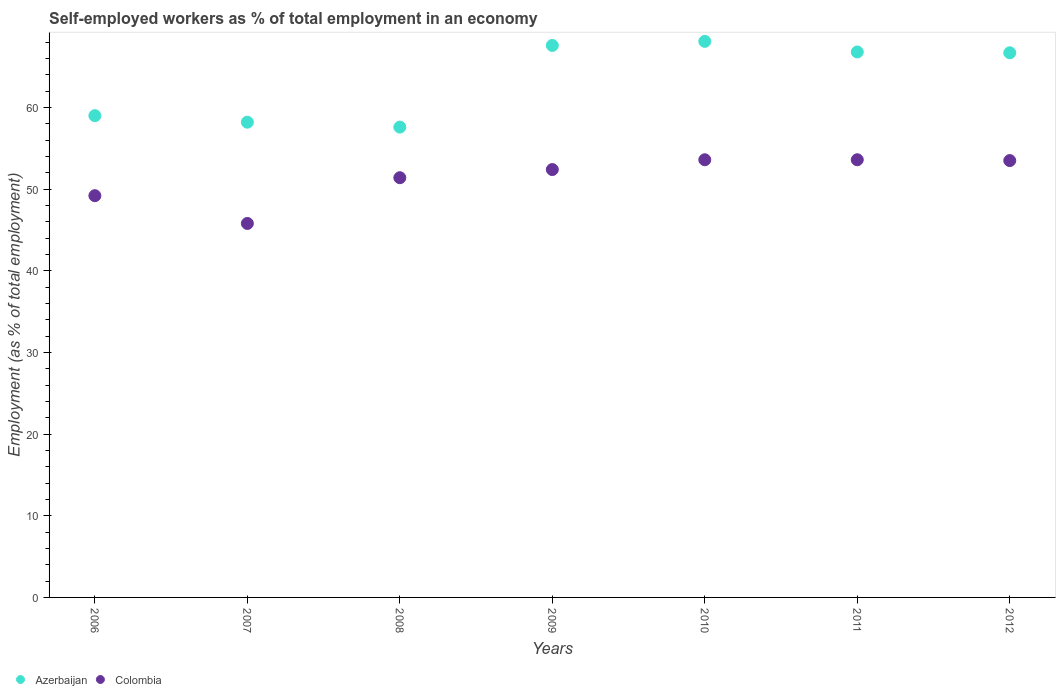How many different coloured dotlines are there?
Your answer should be compact. 2. What is the percentage of self-employed workers in Azerbaijan in 2008?
Your response must be concise. 57.6. Across all years, what is the maximum percentage of self-employed workers in Azerbaijan?
Keep it short and to the point. 68.1. Across all years, what is the minimum percentage of self-employed workers in Azerbaijan?
Give a very brief answer. 57.6. What is the total percentage of self-employed workers in Azerbaijan in the graph?
Your answer should be compact. 444. What is the difference between the percentage of self-employed workers in Azerbaijan in 2009 and that in 2012?
Provide a short and direct response. 0.9. What is the difference between the percentage of self-employed workers in Colombia in 2011 and the percentage of self-employed workers in Azerbaijan in 2012?
Provide a short and direct response. -13.1. What is the average percentage of self-employed workers in Azerbaijan per year?
Give a very brief answer. 63.43. In the year 2011, what is the difference between the percentage of self-employed workers in Colombia and percentage of self-employed workers in Azerbaijan?
Provide a succinct answer. -13.2. In how many years, is the percentage of self-employed workers in Colombia greater than 66 %?
Keep it short and to the point. 0. What is the ratio of the percentage of self-employed workers in Colombia in 2007 to that in 2011?
Keep it short and to the point. 0.85. Is the percentage of self-employed workers in Azerbaijan in 2010 less than that in 2012?
Offer a very short reply. No. What is the difference between the highest and the second highest percentage of self-employed workers in Azerbaijan?
Make the answer very short. 0.5. What is the difference between the highest and the lowest percentage of self-employed workers in Azerbaijan?
Offer a terse response. 10.5. Is the sum of the percentage of self-employed workers in Colombia in 2010 and 2011 greater than the maximum percentage of self-employed workers in Azerbaijan across all years?
Your response must be concise. Yes. Is the percentage of self-employed workers in Colombia strictly less than the percentage of self-employed workers in Azerbaijan over the years?
Your answer should be compact. Yes. How many years are there in the graph?
Make the answer very short. 7. Are the values on the major ticks of Y-axis written in scientific E-notation?
Provide a succinct answer. No. Where does the legend appear in the graph?
Keep it short and to the point. Bottom left. What is the title of the graph?
Your answer should be very brief. Self-employed workers as % of total employment in an economy. What is the label or title of the X-axis?
Provide a short and direct response. Years. What is the label or title of the Y-axis?
Ensure brevity in your answer.  Employment (as % of total employment). What is the Employment (as % of total employment) in Azerbaijan in 2006?
Provide a short and direct response. 59. What is the Employment (as % of total employment) of Colombia in 2006?
Ensure brevity in your answer.  49.2. What is the Employment (as % of total employment) of Azerbaijan in 2007?
Provide a short and direct response. 58.2. What is the Employment (as % of total employment) in Colombia in 2007?
Offer a very short reply. 45.8. What is the Employment (as % of total employment) in Azerbaijan in 2008?
Your answer should be very brief. 57.6. What is the Employment (as % of total employment) in Colombia in 2008?
Provide a succinct answer. 51.4. What is the Employment (as % of total employment) in Azerbaijan in 2009?
Your response must be concise. 67.6. What is the Employment (as % of total employment) of Colombia in 2009?
Offer a very short reply. 52.4. What is the Employment (as % of total employment) in Azerbaijan in 2010?
Keep it short and to the point. 68.1. What is the Employment (as % of total employment) in Colombia in 2010?
Offer a terse response. 53.6. What is the Employment (as % of total employment) of Azerbaijan in 2011?
Offer a terse response. 66.8. What is the Employment (as % of total employment) in Colombia in 2011?
Your response must be concise. 53.6. What is the Employment (as % of total employment) of Azerbaijan in 2012?
Provide a succinct answer. 66.7. What is the Employment (as % of total employment) in Colombia in 2012?
Keep it short and to the point. 53.5. Across all years, what is the maximum Employment (as % of total employment) in Azerbaijan?
Offer a very short reply. 68.1. Across all years, what is the maximum Employment (as % of total employment) in Colombia?
Offer a very short reply. 53.6. Across all years, what is the minimum Employment (as % of total employment) in Azerbaijan?
Ensure brevity in your answer.  57.6. Across all years, what is the minimum Employment (as % of total employment) of Colombia?
Give a very brief answer. 45.8. What is the total Employment (as % of total employment) in Azerbaijan in the graph?
Offer a terse response. 444. What is the total Employment (as % of total employment) of Colombia in the graph?
Make the answer very short. 359.5. What is the difference between the Employment (as % of total employment) in Azerbaijan in 2006 and that in 2007?
Keep it short and to the point. 0.8. What is the difference between the Employment (as % of total employment) of Colombia in 2006 and that in 2007?
Your response must be concise. 3.4. What is the difference between the Employment (as % of total employment) in Azerbaijan in 2006 and that in 2009?
Your response must be concise. -8.6. What is the difference between the Employment (as % of total employment) in Azerbaijan in 2006 and that in 2010?
Provide a succinct answer. -9.1. What is the difference between the Employment (as % of total employment) in Colombia in 2006 and that in 2010?
Your response must be concise. -4.4. What is the difference between the Employment (as % of total employment) of Azerbaijan in 2006 and that in 2011?
Keep it short and to the point. -7.8. What is the difference between the Employment (as % of total employment) of Azerbaijan in 2006 and that in 2012?
Your answer should be compact. -7.7. What is the difference between the Employment (as % of total employment) of Azerbaijan in 2007 and that in 2008?
Your answer should be very brief. 0.6. What is the difference between the Employment (as % of total employment) in Colombia in 2007 and that in 2008?
Offer a very short reply. -5.6. What is the difference between the Employment (as % of total employment) in Colombia in 2007 and that in 2009?
Offer a terse response. -6.6. What is the difference between the Employment (as % of total employment) of Azerbaijan in 2007 and that in 2011?
Keep it short and to the point. -8.6. What is the difference between the Employment (as % of total employment) of Colombia in 2007 and that in 2012?
Provide a short and direct response. -7.7. What is the difference between the Employment (as % of total employment) in Colombia in 2008 and that in 2010?
Keep it short and to the point. -2.2. What is the difference between the Employment (as % of total employment) of Azerbaijan in 2008 and that in 2011?
Make the answer very short. -9.2. What is the difference between the Employment (as % of total employment) in Azerbaijan in 2008 and that in 2012?
Provide a short and direct response. -9.1. What is the difference between the Employment (as % of total employment) of Colombia in 2008 and that in 2012?
Provide a succinct answer. -2.1. What is the difference between the Employment (as % of total employment) of Azerbaijan in 2009 and that in 2011?
Provide a short and direct response. 0.8. What is the difference between the Employment (as % of total employment) in Colombia in 2009 and that in 2012?
Keep it short and to the point. -1.1. What is the difference between the Employment (as % of total employment) in Azerbaijan in 2010 and that in 2011?
Offer a very short reply. 1.3. What is the difference between the Employment (as % of total employment) in Azerbaijan in 2011 and that in 2012?
Ensure brevity in your answer.  0.1. What is the difference between the Employment (as % of total employment) in Azerbaijan in 2006 and the Employment (as % of total employment) in Colombia in 2009?
Your answer should be compact. 6.6. What is the difference between the Employment (as % of total employment) in Azerbaijan in 2006 and the Employment (as % of total employment) in Colombia in 2011?
Give a very brief answer. 5.4. What is the difference between the Employment (as % of total employment) of Azerbaijan in 2007 and the Employment (as % of total employment) of Colombia in 2008?
Your response must be concise. 6.8. What is the difference between the Employment (as % of total employment) in Azerbaijan in 2007 and the Employment (as % of total employment) in Colombia in 2009?
Keep it short and to the point. 5.8. What is the difference between the Employment (as % of total employment) in Azerbaijan in 2007 and the Employment (as % of total employment) in Colombia in 2011?
Ensure brevity in your answer.  4.6. What is the difference between the Employment (as % of total employment) of Azerbaijan in 2007 and the Employment (as % of total employment) of Colombia in 2012?
Give a very brief answer. 4.7. What is the difference between the Employment (as % of total employment) in Azerbaijan in 2008 and the Employment (as % of total employment) in Colombia in 2012?
Your answer should be compact. 4.1. What is the difference between the Employment (as % of total employment) of Azerbaijan in 2009 and the Employment (as % of total employment) of Colombia in 2011?
Offer a very short reply. 14. What is the difference between the Employment (as % of total employment) in Azerbaijan in 2009 and the Employment (as % of total employment) in Colombia in 2012?
Give a very brief answer. 14.1. What is the difference between the Employment (as % of total employment) in Azerbaijan in 2011 and the Employment (as % of total employment) in Colombia in 2012?
Make the answer very short. 13.3. What is the average Employment (as % of total employment) of Azerbaijan per year?
Your answer should be compact. 63.43. What is the average Employment (as % of total employment) in Colombia per year?
Your answer should be very brief. 51.36. In the year 2006, what is the difference between the Employment (as % of total employment) in Azerbaijan and Employment (as % of total employment) in Colombia?
Keep it short and to the point. 9.8. In the year 2007, what is the difference between the Employment (as % of total employment) of Azerbaijan and Employment (as % of total employment) of Colombia?
Keep it short and to the point. 12.4. In the year 2008, what is the difference between the Employment (as % of total employment) of Azerbaijan and Employment (as % of total employment) of Colombia?
Offer a terse response. 6.2. In the year 2010, what is the difference between the Employment (as % of total employment) of Azerbaijan and Employment (as % of total employment) of Colombia?
Keep it short and to the point. 14.5. In the year 2011, what is the difference between the Employment (as % of total employment) of Azerbaijan and Employment (as % of total employment) of Colombia?
Provide a short and direct response. 13.2. In the year 2012, what is the difference between the Employment (as % of total employment) of Azerbaijan and Employment (as % of total employment) of Colombia?
Ensure brevity in your answer.  13.2. What is the ratio of the Employment (as % of total employment) of Azerbaijan in 2006 to that in 2007?
Provide a succinct answer. 1.01. What is the ratio of the Employment (as % of total employment) of Colombia in 2006 to that in 2007?
Give a very brief answer. 1.07. What is the ratio of the Employment (as % of total employment) of Azerbaijan in 2006 to that in 2008?
Keep it short and to the point. 1.02. What is the ratio of the Employment (as % of total employment) of Colombia in 2006 to that in 2008?
Offer a terse response. 0.96. What is the ratio of the Employment (as % of total employment) of Azerbaijan in 2006 to that in 2009?
Provide a succinct answer. 0.87. What is the ratio of the Employment (as % of total employment) of Colombia in 2006 to that in 2009?
Your answer should be compact. 0.94. What is the ratio of the Employment (as % of total employment) of Azerbaijan in 2006 to that in 2010?
Your answer should be very brief. 0.87. What is the ratio of the Employment (as % of total employment) in Colombia in 2006 to that in 2010?
Give a very brief answer. 0.92. What is the ratio of the Employment (as % of total employment) of Azerbaijan in 2006 to that in 2011?
Your response must be concise. 0.88. What is the ratio of the Employment (as % of total employment) of Colombia in 2006 to that in 2011?
Your answer should be compact. 0.92. What is the ratio of the Employment (as % of total employment) in Azerbaijan in 2006 to that in 2012?
Keep it short and to the point. 0.88. What is the ratio of the Employment (as % of total employment) of Colombia in 2006 to that in 2012?
Keep it short and to the point. 0.92. What is the ratio of the Employment (as % of total employment) of Azerbaijan in 2007 to that in 2008?
Ensure brevity in your answer.  1.01. What is the ratio of the Employment (as % of total employment) of Colombia in 2007 to that in 2008?
Provide a succinct answer. 0.89. What is the ratio of the Employment (as % of total employment) of Azerbaijan in 2007 to that in 2009?
Provide a short and direct response. 0.86. What is the ratio of the Employment (as % of total employment) in Colombia in 2007 to that in 2009?
Keep it short and to the point. 0.87. What is the ratio of the Employment (as % of total employment) of Azerbaijan in 2007 to that in 2010?
Your response must be concise. 0.85. What is the ratio of the Employment (as % of total employment) of Colombia in 2007 to that in 2010?
Your response must be concise. 0.85. What is the ratio of the Employment (as % of total employment) in Azerbaijan in 2007 to that in 2011?
Give a very brief answer. 0.87. What is the ratio of the Employment (as % of total employment) of Colombia in 2007 to that in 2011?
Ensure brevity in your answer.  0.85. What is the ratio of the Employment (as % of total employment) in Azerbaijan in 2007 to that in 2012?
Your answer should be compact. 0.87. What is the ratio of the Employment (as % of total employment) in Colombia in 2007 to that in 2012?
Provide a succinct answer. 0.86. What is the ratio of the Employment (as % of total employment) of Azerbaijan in 2008 to that in 2009?
Your answer should be compact. 0.85. What is the ratio of the Employment (as % of total employment) of Colombia in 2008 to that in 2009?
Give a very brief answer. 0.98. What is the ratio of the Employment (as % of total employment) in Azerbaijan in 2008 to that in 2010?
Offer a terse response. 0.85. What is the ratio of the Employment (as % of total employment) in Colombia in 2008 to that in 2010?
Make the answer very short. 0.96. What is the ratio of the Employment (as % of total employment) of Azerbaijan in 2008 to that in 2011?
Your answer should be very brief. 0.86. What is the ratio of the Employment (as % of total employment) of Colombia in 2008 to that in 2011?
Provide a short and direct response. 0.96. What is the ratio of the Employment (as % of total employment) of Azerbaijan in 2008 to that in 2012?
Give a very brief answer. 0.86. What is the ratio of the Employment (as % of total employment) in Colombia in 2008 to that in 2012?
Provide a short and direct response. 0.96. What is the ratio of the Employment (as % of total employment) in Azerbaijan in 2009 to that in 2010?
Offer a very short reply. 0.99. What is the ratio of the Employment (as % of total employment) in Colombia in 2009 to that in 2010?
Keep it short and to the point. 0.98. What is the ratio of the Employment (as % of total employment) in Colombia in 2009 to that in 2011?
Give a very brief answer. 0.98. What is the ratio of the Employment (as % of total employment) in Azerbaijan in 2009 to that in 2012?
Ensure brevity in your answer.  1.01. What is the ratio of the Employment (as % of total employment) in Colombia in 2009 to that in 2012?
Give a very brief answer. 0.98. What is the ratio of the Employment (as % of total employment) in Azerbaijan in 2010 to that in 2011?
Your answer should be very brief. 1.02. What is the ratio of the Employment (as % of total employment) in Colombia in 2010 to that in 2012?
Keep it short and to the point. 1. What is the difference between the highest and the second highest Employment (as % of total employment) in Colombia?
Give a very brief answer. 0. What is the difference between the highest and the lowest Employment (as % of total employment) of Azerbaijan?
Keep it short and to the point. 10.5. What is the difference between the highest and the lowest Employment (as % of total employment) in Colombia?
Ensure brevity in your answer.  7.8. 